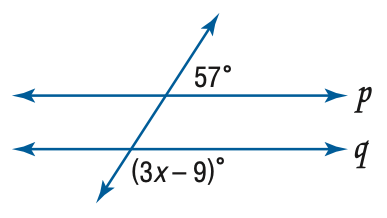Answer the mathemtical geometry problem and directly provide the correct option letter.
Question: Find x so that p \parallel q.
Choices: A: 16 B: 22 C: 44 D: 66 C 